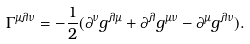<formula> <loc_0><loc_0><loc_500><loc_500>\Gamma ^ { \mu \lambda \nu } = - { \frac { 1 } { 2 } } ( \partial ^ { \nu } g ^ { \lambda \mu } + \partial ^ { \lambda } g ^ { \mu \nu } - \partial ^ { \mu } g ^ { \lambda \nu } ) .</formula> 